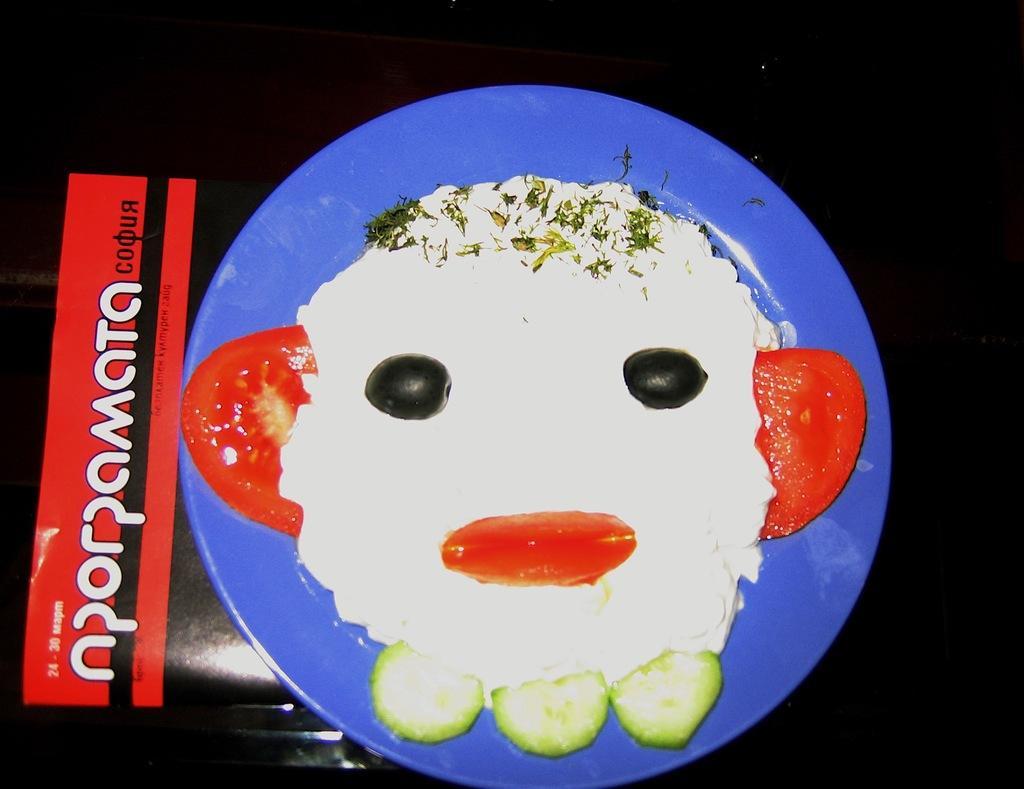In one or two sentences, can you explain what this image depicts? In this picture there is a plate in the center of the image, which contains food items in it. 